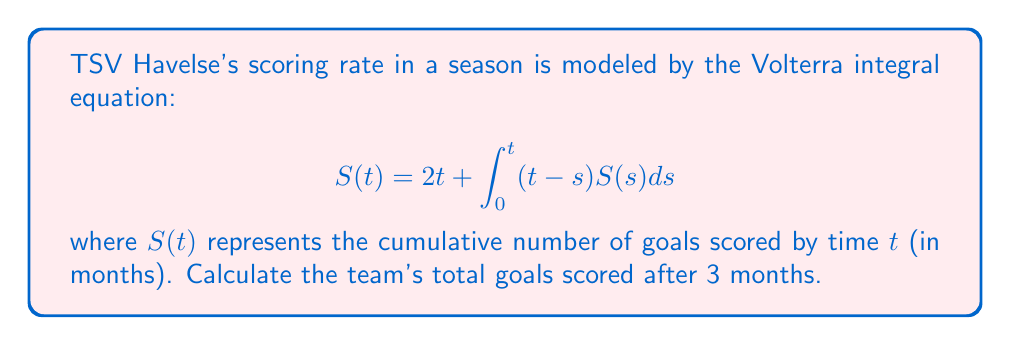Solve this math problem. To solve this Volterra integral equation and find $S(3)$, we'll follow these steps:

1) First, we need to differentiate both sides of the equation with respect to $t$:

   $$S'(t) = 2 + \int_0^t S(s)ds + (t-t)S(t) = 2 + \int_0^t S(s)ds$$

2) Differentiating again:

   $$S''(t) = S(t)$$

3) This is a second-order linear differential equation. The general solution is:

   $$S(t) = A\cosh(t) + B\sinh(t)$$

4) To find $A$ and $B$, we use the initial conditions:
   
   At $t=0$: $S(0) = 0$, so $A = 0$
   
   At $t=0$: $S'(0) = 2$, so $B = 2$

5) Therefore, the particular solution is:

   $$S(t) = 2\sinh(t)$$

6) To find the total goals after 3 months, we calculate $S(3)$:

   $$S(3) = 2\sinh(3) \approx 20.0357$$

7) Since we're dealing with goals, we round down to the nearest whole number.
Answer: 20 goals 